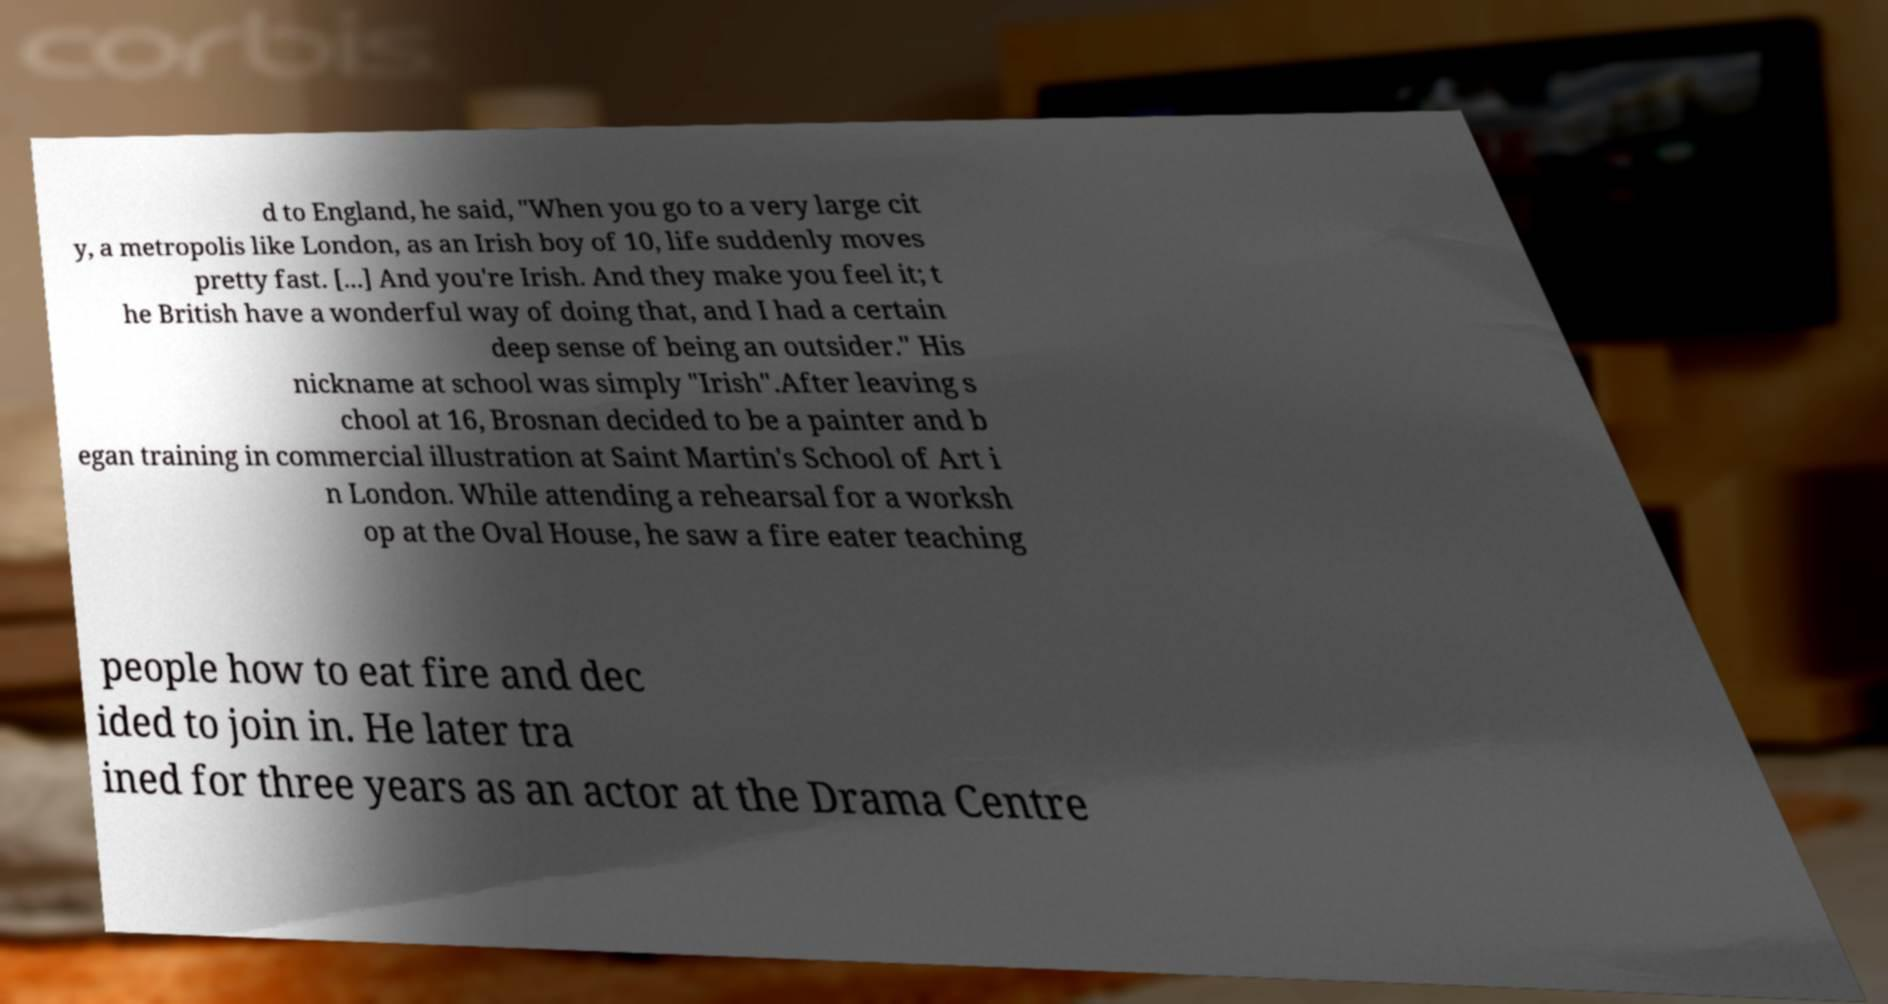Could you assist in decoding the text presented in this image and type it out clearly? d to England, he said, "When you go to a very large cit y, a metropolis like London, as an Irish boy of 10, life suddenly moves pretty fast. [...] And you're Irish. And they make you feel it; t he British have a wonderful way of doing that, and I had a certain deep sense of being an outsider." His nickname at school was simply "Irish".After leaving s chool at 16, Brosnan decided to be a painter and b egan training in commercial illustration at Saint Martin's School of Art i n London. While attending a rehearsal for a worksh op at the Oval House, he saw a fire eater teaching people how to eat fire and dec ided to join in. He later tra ined for three years as an actor at the Drama Centre 